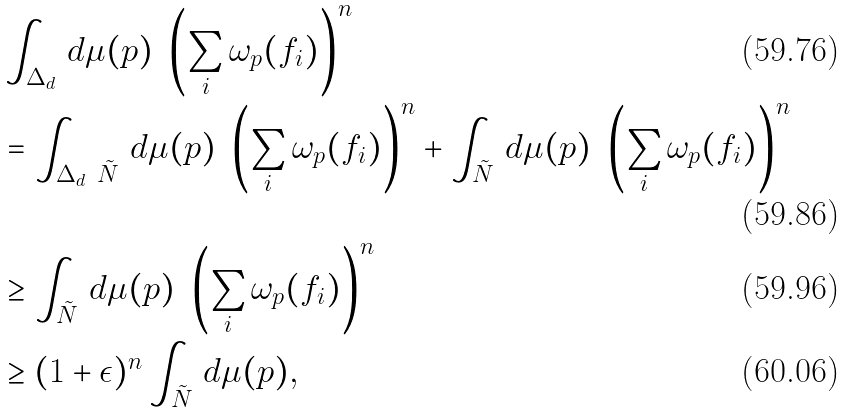Convert formula to latex. <formula><loc_0><loc_0><loc_500><loc_500>& \int _ { \Delta _ { d } } \, d \mu ( p ) \ \left ( \sum _ { i } \omega _ { p } ( f _ { i } ) \right ) ^ { n } \\ & = \int _ { \Delta _ { d } \ \tilde { N } } \, d \mu ( p ) \ \left ( \sum _ { i } \omega _ { p } ( f _ { i } ) \right ) ^ { n } + \int _ { \tilde { N } } \, d \mu ( p ) \ \left ( \sum _ { i } \omega _ { p } ( f _ { i } ) \right ) ^ { n } \\ & \geq \int _ { \tilde { N } } \, d \mu ( p ) \ \left ( \sum _ { i } \omega _ { p } ( f _ { i } ) \right ) ^ { n } \\ & \geq ( 1 + \epsilon ) ^ { n } \int _ { \tilde { N } } \, d \mu ( p ) ,</formula> 